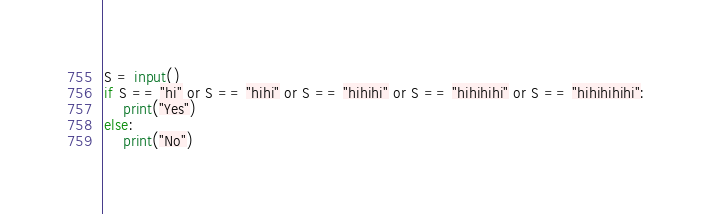Convert code to text. <code><loc_0><loc_0><loc_500><loc_500><_Python_>S = input()
if S == "hi" or S == "hihi" or S == "hihihi" or S == "hihihihi" or S == "hihihihihi":
    print("Yes")
else:
    print("No")</code> 